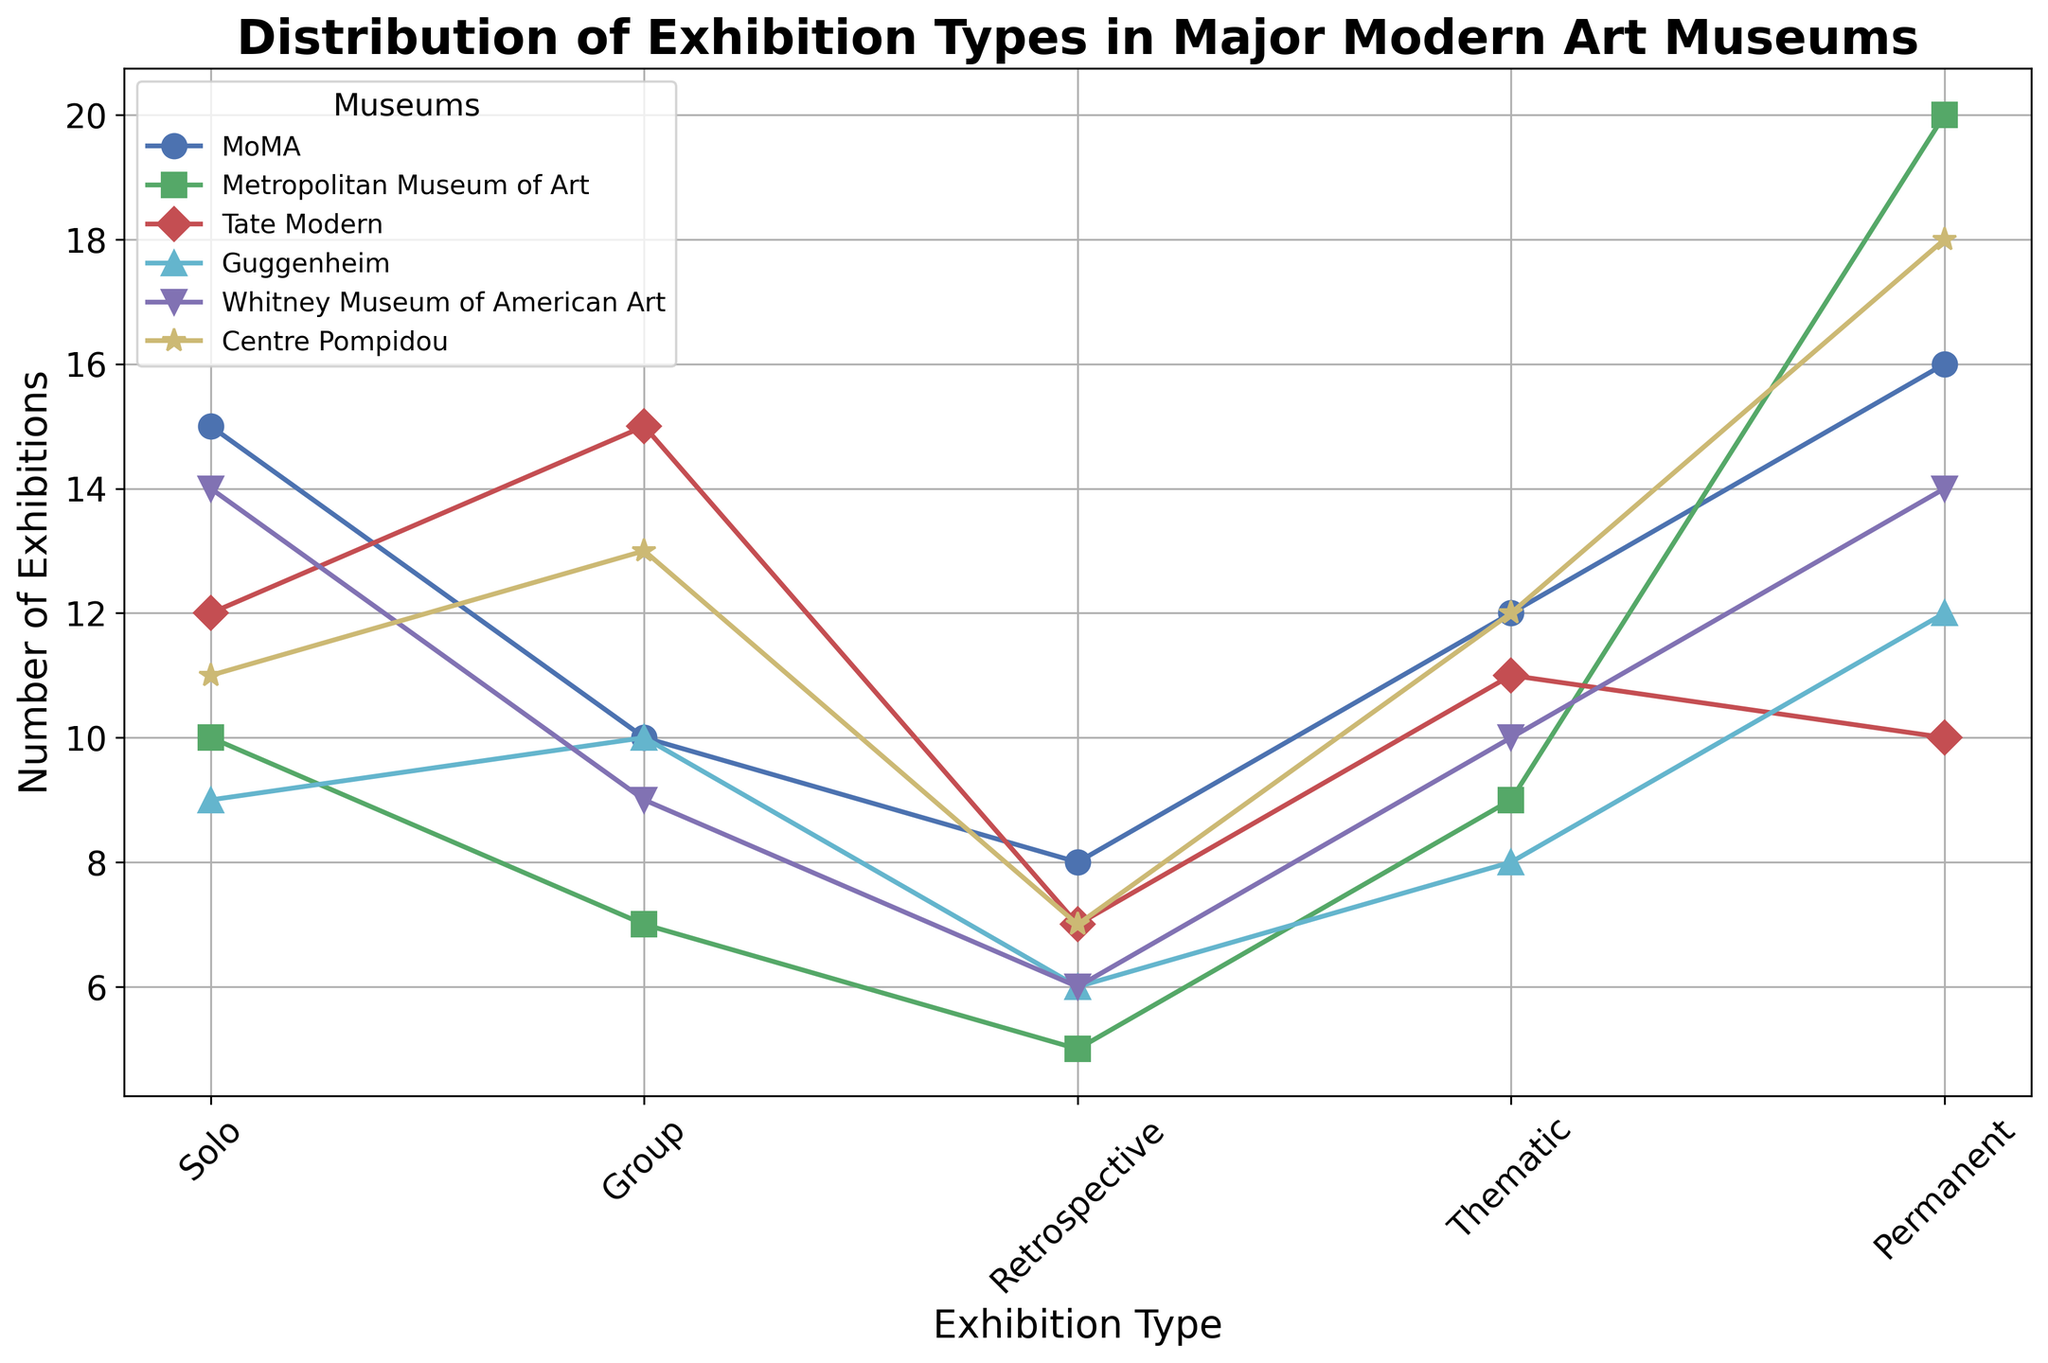How many more solo exhibitions does the MoMA have compared to retrospectives at the Guggenheim? The figure shows that MoMA has 15 solo exhibitions, and the Guggenheim has 6 retrospectives. The difference is 15 - 6.
Answer: 9 Which museum has the least number of solo exhibitions? By examining the figure, we find that the Guggenheim has the least number of solo exhibitions, with a count of 9.
Answer: Guggenheim Are there more permanent exhibitions in the Centre Pompidou or thematic exhibitions at the Tate Modern? The figure shows that the Centre Pompidou has 18 permanent exhibitions and the Tate Modern has 11 thematic exhibitions. 18 is greater than 11.
Answer: Centre Pompidou What is the average number of group exhibitions across all museums? To find the average, add the number of group exhibitions for all museums: 10 + 7 + 15 + 10 + 9 + 13 = 64. Divide by the total number of museums, which is 6. So, 64 / 6.
Answer: 10.67 How many total thematic exhibitions are there in the MoMA and Whitney Museum of American Art combined? The figure shows that MoMA has 12 thematic exhibitions, and the Whitney Museum of American Art has 10 thematic exhibitions. Therefore, the total is 12 + 10.
Answer: 22 Which museum has the highest number of permanent exhibitions, and what is the count? By examining the figure, the Metropolitan Museum of Art has the highest number of permanent exhibitions, with a count of 20.
Answer: Metropolitan Museum of Art, 20 Compare the number of retrospective exhibitions between the MoMA and Centre Pompidou. Which has more? The figure shows that MoMA has 8 retrospectives, while the Centre Pompidou has 7. MoMA has more.
Answer: MoMA What is the median number of solo exhibitions among all the museums? The solo exhibitions counts are: 15, 10, 12, 9, 14, 11. Arranging them in ascending order: 9, 10, 11, 12, 14, 15. The median is the average of the middle two numbers: (11 + 12) / 2.
Answer: 11.5 Does the Whitney Museum of American Art have more group or solo exhibitions? The figure shows that the Whitney has 9 group exhibitions and 14 solo exhibitions. 14 is more than 9.
Answer: Solo exhibitions 